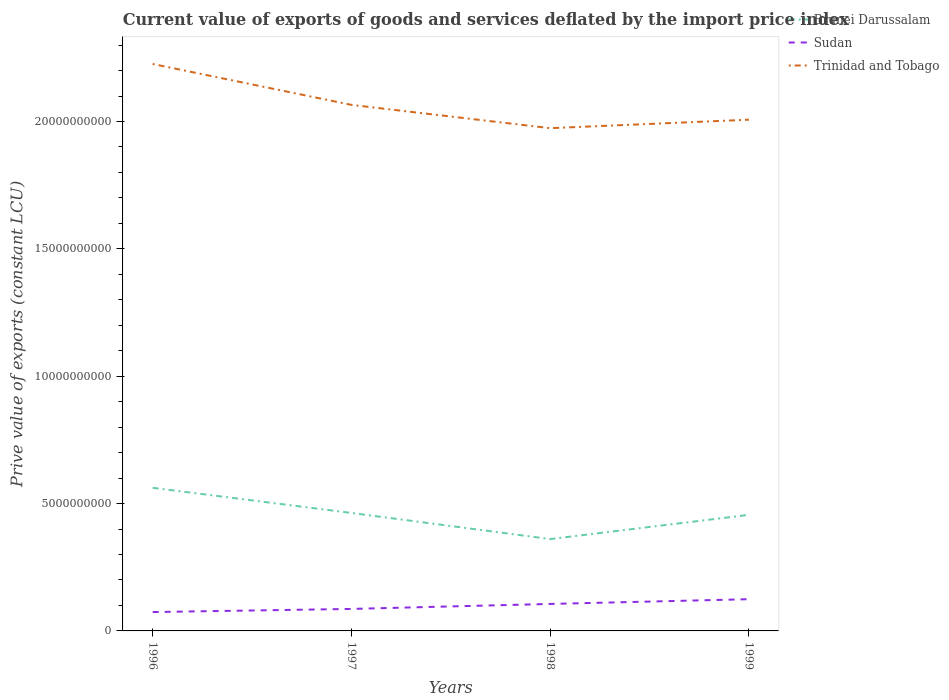Is the number of lines equal to the number of legend labels?
Provide a short and direct response. Yes. Across all years, what is the maximum prive value of exports in Trinidad and Tobago?
Provide a short and direct response. 1.97e+1. In which year was the prive value of exports in Trinidad and Tobago maximum?
Provide a succinct answer. 1998. What is the total prive value of exports in Sudan in the graph?
Provide a short and direct response. -1.96e+08. What is the difference between the highest and the second highest prive value of exports in Brunei Darussalam?
Offer a very short reply. 2.01e+09. What is the difference between the highest and the lowest prive value of exports in Trinidad and Tobago?
Provide a short and direct response. 1. Is the prive value of exports in Trinidad and Tobago strictly greater than the prive value of exports in Brunei Darussalam over the years?
Your answer should be very brief. No. How many lines are there?
Your answer should be very brief. 3. Are the values on the major ticks of Y-axis written in scientific E-notation?
Offer a terse response. No. What is the title of the graph?
Ensure brevity in your answer.  Current value of exports of goods and services deflated by the import price index. Does "Switzerland" appear as one of the legend labels in the graph?
Provide a succinct answer. No. What is the label or title of the X-axis?
Provide a short and direct response. Years. What is the label or title of the Y-axis?
Ensure brevity in your answer.  Prive value of exports (constant LCU). What is the Prive value of exports (constant LCU) in Brunei Darussalam in 1996?
Your response must be concise. 5.62e+09. What is the Prive value of exports (constant LCU) of Sudan in 1996?
Your response must be concise. 7.40e+08. What is the Prive value of exports (constant LCU) in Trinidad and Tobago in 1996?
Keep it short and to the point. 2.23e+1. What is the Prive value of exports (constant LCU) of Brunei Darussalam in 1997?
Ensure brevity in your answer.  4.63e+09. What is the Prive value of exports (constant LCU) of Sudan in 1997?
Your answer should be very brief. 8.64e+08. What is the Prive value of exports (constant LCU) in Trinidad and Tobago in 1997?
Your answer should be very brief. 2.07e+1. What is the Prive value of exports (constant LCU) in Brunei Darussalam in 1998?
Provide a succinct answer. 3.61e+09. What is the Prive value of exports (constant LCU) in Sudan in 1998?
Offer a very short reply. 1.06e+09. What is the Prive value of exports (constant LCU) of Trinidad and Tobago in 1998?
Your response must be concise. 1.97e+1. What is the Prive value of exports (constant LCU) in Brunei Darussalam in 1999?
Keep it short and to the point. 4.56e+09. What is the Prive value of exports (constant LCU) in Sudan in 1999?
Offer a very short reply. 1.25e+09. What is the Prive value of exports (constant LCU) in Trinidad and Tobago in 1999?
Provide a succinct answer. 2.01e+1. Across all years, what is the maximum Prive value of exports (constant LCU) of Brunei Darussalam?
Provide a succinct answer. 5.62e+09. Across all years, what is the maximum Prive value of exports (constant LCU) of Sudan?
Your answer should be compact. 1.25e+09. Across all years, what is the maximum Prive value of exports (constant LCU) of Trinidad and Tobago?
Offer a very short reply. 2.23e+1. Across all years, what is the minimum Prive value of exports (constant LCU) of Brunei Darussalam?
Your answer should be very brief. 3.61e+09. Across all years, what is the minimum Prive value of exports (constant LCU) in Sudan?
Make the answer very short. 7.40e+08. Across all years, what is the minimum Prive value of exports (constant LCU) of Trinidad and Tobago?
Your response must be concise. 1.97e+1. What is the total Prive value of exports (constant LCU) of Brunei Darussalam in the graph?
Your answer should be very brief. 1.84e+1. What is the total Prive value of exports (constant LCU) of Sudan in the graph?
Your answer should be compact. 3.91e+09. What is the total Prive value of exports (constant LCU) of Trinidad and Tobago in the graph?
Offer a very short reply. 8.27e+1. What is the difference between the Prive value of exports (constant LCU) of Brunei Darussalam in 1996 and that in 1997?
Provide a succinct answer. 9.87e+08. What is the difference between the Prive value of exports (constant LCU) in Sudan in 1996 and that in 1997?
Give a very brief answer. -1.23e+08. What is the difference between the Prive value of exports (constant LCU) in Trinidad and Tobago in 1996 and that in 1997?
Provide a succinct answer. 1.61e+09. What is the difference between the Prive value of exports (constant LCU) of Brunei Darussalam in 1996 and that in 1998?
Your answer should be compact. 2.01e+09. What is the difference between the Prive value of exports (constant LCU) in Sudan in 1996 and that in 1998?
Your response must be concise. -3.19e+08. What is the difference between the Prive value of exports (constant LCU) in Trinidad and Tobago in 1996 and that in 1998?
Offer a terse response. 2.52e+09. What is the difference between the Prive value of exports (constant LCU) of Brunei Darussalam in 1996 and that in 1999?
Offer a very short reply. 1.06e+09. What is the difference between the Prive value of exports (constant LCU) of Sudan in 1996 and that in 1999?
Offer a terse response. -5.05e+08. What is the difference between the Prive value of exports (constant LCU) in Trinidad and Tobago in 1996 and that in 1999?
Your answer should be compact. 2.19e+09. What is the difference between the Prive value of exports (constant LCU) of Brunei Darussalam in 1997 and that in 1998?
Offer a very short reply. 1.03e+09. What is the difference between the Prive value of exports (constant LCU) of Sudan in 1997 and that in 1998?
Your answer should be very brief. -1.96e+08. What is the difference between the Prive value of exports (constant LCU) in Trinidad and Tobago in 1997 and that in 1998?
Offer a terse response. 9.15e+08. What is the difference between the Prive value of exports (constant LCU) in Brunei Darussalam in 1997 and that in 1999?
Your response must be concise. 7.47e+07. What is the difference between the Prive value of exports (constant LCU) of Sudan in 1997 and that in 1999?
Your response must be concise. -3.82e+08. What is the difference between the Prive value of exports (constant LCU) of Trinidad and Tobago in 1997 and that in 1999?
Ensure brevity in your answer.  5.82e+08. What is the difference between the Prive value of exports (constant LCU) in Brunei Darussalam in 1998 and that in 1999?
Provide a short and direct response. -9.52e+08. What is the difference between the Prive value of exports (constant LCU) of Sudan in 1998 and that in 1999?
Provide a short and direct response. -1.86e+08. What is the difference between the Prive value of exports (constant LCU) of Trinidad and Tobago in 1998 and that in 1999?
Your response must be concise. -3.33e+08. What is the difference between the Prive value of exports (constant LCU) in Brunei Darussalam in 1996 and the Prive value of exports (constant LCU) in Sudan in 1997?
Provide a short and direct response. 4.75e+09. What is the difference between the Prive value of exports (constant LCU) of Brunei Darussalam in 1996 and the Prive value of exports (constant LCU) of Trinidad and Tobago in 1997?
Your answer should be very brief. -1.50e+1. What is the difference between the Prive value of exports (constant LCU) of Sudan in 1996 and the Prive value of exports (constant LCU) of Trinidad and Tobago in 1997?
Offer a very short reply. -1.99e+1. What is the difference between the Prive value of exports (constant LCU) of Brunei Darussalam in 1996 and the Prive value of exports (constant LCU) of Sudan in 1998?
Offer a very short reply. 4.56e+09. What is the difference between the Prive value of exports (constant LCU) in Brunei Darussalam in 1996 and the Prive value of exports (constant LCU) in Trinidad and Tobago in 1998?
Give a very brief answer. -1.41e+1. What is the difference between the Prive value of exports (constant LCU) in Sudan in 1996 and the Prive value of exports (constant LCU) in Trinidad and Tobago in 1998?
Ensure brevity in your answer.  -1.90e+1. What is the difference between the Prive value of exports (constant LCU) in Brunei Darussalam in 1996 and the Prive value of exports (constant LCU) in Sudan in 1999?
Give a very brief answer. 4.37e+09. What is the difference between the Prive value of exports (constant LCU) in Brunei Darussalam in 1996 and the Prive value of exports (constant LCU) in Trinidad and Tobago in 1999?
Offer a very short reply. -1.45e+1. What is the difference between the Prive value of exports (constant LCU) of Sudan in 1996 and the Prive value of exports (constant LCU) of Trinidad and Tobago in 1999?
Make the answer very short. -1.93e+1. What is the difference between the Prive value of exports (constant LCU) of Brunei Darussalam in 1997 and the Prive value of exports (constant LCU) of Sudan in 1998?
Ensure brevity in your answer.  3.57e+09. What is the difference between the Prive value of exports (constant LCU) of Brunei Darussalam in 1997 and the Prive value of exports (constant LCU) of Trinidad and Tobago in 1998?
Your response must be concise. -1.51e+1. What is the difference between the Prive value of exports (constant LCU) of Sudan in 1997 and the Prive value of exports (constant LCU) of Trinidad and Tobago in 1998?
Ensure brevity in your answer.  -1.89e+1. What is the difference between the Prive value of exports (constant LCU) of Brunei Darussalam in 1997 and the Prive value of exports (constant LCU) of Sudan in 1999?
Your answer should be compact. 3.39e+09. What is the difference between the Prive value of exports (constant LCU) of Brunei Darussalam in 1997 and the Prive value of exports (constant LCU) of Trinidad and Tobago in 1999?
Ensure brevity in your answer.  -1.54e+1. What is the difference between the Prive value of exports (constant LCU) of Sudan in 1997 and the Prive value of exports (constant LCU) of Trinidad and Tobago in 1999?
Provide a short and direct response. -1.92e+1. What is the difference between the Prive value of exports (constant LCU) in Brunei Darussalam in 1998 and the Prive value of exports (constant LCU) in Sudan in 1999?
Ensure brevity in your answer.  2.36e+09. What is the difference between the Prive value of exports (constant LCU) in Brunei Darussalam in 1998 and the Prive value of exports (constant LCU) in Trinidad and Tobago in 1999?
Offer a very short reply. -1.65e+1. What is the difference between the Prive value of exports (constant LCU) of Sudan in 1998 and the Prive value of exports (constant LCU) of Trinidad and Tobago in 1999?
Keep it short and to the point. -1.90e+1. What is the average Prive value of exports (constant LCU) in Brunei Darussalam per year?
Provide a short and direct response. 4.60e+09. What is the average Prive value of exports (constant LCU) in Sudan per year?
Your response must be concise. 9.77e+08. What is the average Prive value of exports (constant LCU) in Trinidad and Tobago per year?
Your answer should be compact. 2.07e+1. In the year 1996, what is the difference between the Prive value of exports (constant LCU) in Brunei Darussalam and Prive value of exports (constant LCU) in Sudan?
Make the answer very short. 4.88e+09. In the year 1996, what is the difference between the Prive value of exports (constant LCU) in Brunei Darussalam and Prive value of exports (constant LCU) in Trinidad and Tobago?
Your answer should be compact. -1.66e+1. In the year 1996, what is the difference between the Prive value of exports (constant LCU) of Sudan and Prive value of exports (constant LCU) of Trinidad and Tobago?
Give a very brief answer. -2.15e+1. In the year 1997, what is the difference between the Prive value of exports (constant LCU) of Brunei Darussalam and Prive value of exports (constant LCU) of Sudan?
Provide a short and direct response. 3.77e+09. In the year 1997, what is the difference between the Prive value of exports (constant LCU) of Brunei Darussalam and Prive value of exports (constant LCU) of Trinidad and Tobago?
Your response must be concise. -1.60e+1. In the year 1997, what is the difference between the Prive value of exports (constant LCU) of Sudan and Prive value of exports (constant LCU) of Trinidad and Tobago?
Your answer should be compact. -1.98e+1. In the year 1998, what is the difference between the Prive value of exports (constant LCU) in Brunei Darussalam and Prive value of exports (constant LCU) in Sudan?
Keep it short and to the point. 2.55e+09. In the year 1998, what is the difference between the Prive value of exports (constant LCU) in Brunei Darussalam and Prive value of exports (constant LCU) in Trinidad and Tobago?
Your answer should be compact. -1.61e+1. In the year 1998, what is the difference between the Prive value of exports (constant LCU) in Sudan and Prive value of exports (constant LCU) in Trinidad and Tobago?
Your answer should be compact. -1.87e+1. In the year 1999, what is the difference between the Prive value of exports (constant LCU) of Brunei Darussalam and Prive value of exports (constant LCU) of Sudan?
Make the answer very short. 3.31e+09. In the year 1999, what is the difference between the Prive value of exports (constant LCU) of Brunei Darussalam and Prive value of exports (constant LCU) of Trinidad and Tobago?
Give a very brief answer. -1.55e+1. In the year 1999, what is the difference between the Prive value of exports (constant LCU) in Sudan and Prive value of exports (constant LCU) in Trinidad and Tobago?
Your answer should be very brief. -1.88e+1. What is the ratio of the Prive value of exports (constant LCU) in Brunei Darussalam in 1996 to that in 1997?
Your answer should be very brief. 1.21. What is the ratio of the Prive value of exports (constant LCU) in Trinidad and Tobago in 1996 to that in 1997?
Provide a short and direct response. 1.08. What is the ratio of the Prive value of exports (constant LCU) in Brunei Darussalam in 1996 to that in 1998?
Give a very brief answer. 1.56. What is the ratio of the Prive value of exports (constant LCU) in Sudan in 1996 to that in 1998?
Keep it short and to the point. 0.7. What is the ratio of the Prive value of exports (constant LCU) in Trinidad and Tobago in 1996 to that in 1998?
Your answer should be very brief. 1.13. What is the ratio of the Prive value of exports (constant LCU) in Brunei Darussalam in 1996 to that in 1999?
Provide a succinct answer. 1.23. What is the ratio of the Prive value of exports (constant LCU) of Sudan in 1996 to that in 1999?
Offer a very short reply. 0.59. What is the ratio of the Prive value of exports (constant LCU) in Trinidad and Tobago in 1996 to that in 1999?
Your response must be concise. 1.11. What is the ratio of the Prive value of exports (constant LCU) of Brunei Darussalam in 1997 to that in 1998?
Keep it short and to the point. 1.28. What is the ratio of the Prive value of exports (constant LCU) of Sudan in 1997 to that in 1998?
Your answer should be very brief. 0.82. What is the ratio of the Prive value of exports (constant LCU) of Trinidad and Tobago in 1997 to that in 1998?
Provide a short and direct response. 1.05. What is the ratio of the Prive value of exports (constant LCU) in Brunei Darussalam in 1997 to that in 1999?
Keep it short and to the point. 1.02. What is the ratio of the Prive value of exports (constant LCU) in Sudan in 1997 to that in 1999?
Your answer should be very brief. 0.69. What is the ratio of the Prive value of exports (constant LCU) in Brunei Darussalam in 1998 to that in 1999?
Make the answer very short. 0.79. What is the ratio of the Prive value of exports (constant LCU) of Sudan in 1998 to that in 1999?
Provide a short and direct response. 0.85. What is the ratio of the Prive value of exports (constant LCU) in Trinidad and Tobago in 1998 to that in 1999?
Offer a terse response. 0.98. What is the difference between the highest and the second highest Prive value of exports (constant LCU) in Brunei Darussalam?
Ensure brevity in your answer.  9.87e+08. What is the difference between the highest and the second highest Prive value of exports (constant LCU) in Sudan?
Your response must be concise. 1.86e+08. What is the difference between the highest and the second highest Prive value of exports (constant LCU) of Trinidad and Tobago?
Keep it short and to the point. 1.61e+09. What is the difference between the highest and the lowest Prive value of exports (constant LCU) of Brunei Darussalam?
Give a very brief answer. 2.01e+09. What is the difference between the highest and the lowest Prive value of exports (constant LCU) in Sudan?
Your response must be concise. 5.05e+08. What is the difference between the highest and the lowest Prive value of exports (constant LCU) in Trinidad and Tobago?
Give a very brief answer. 2.52e+09. 